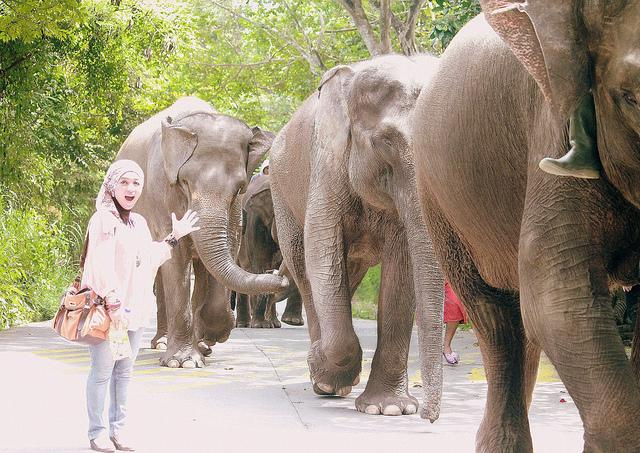What is the expression on the woman's face?

Choices:
A) worry
B) scare
C) excitement
D) disgust excitement 